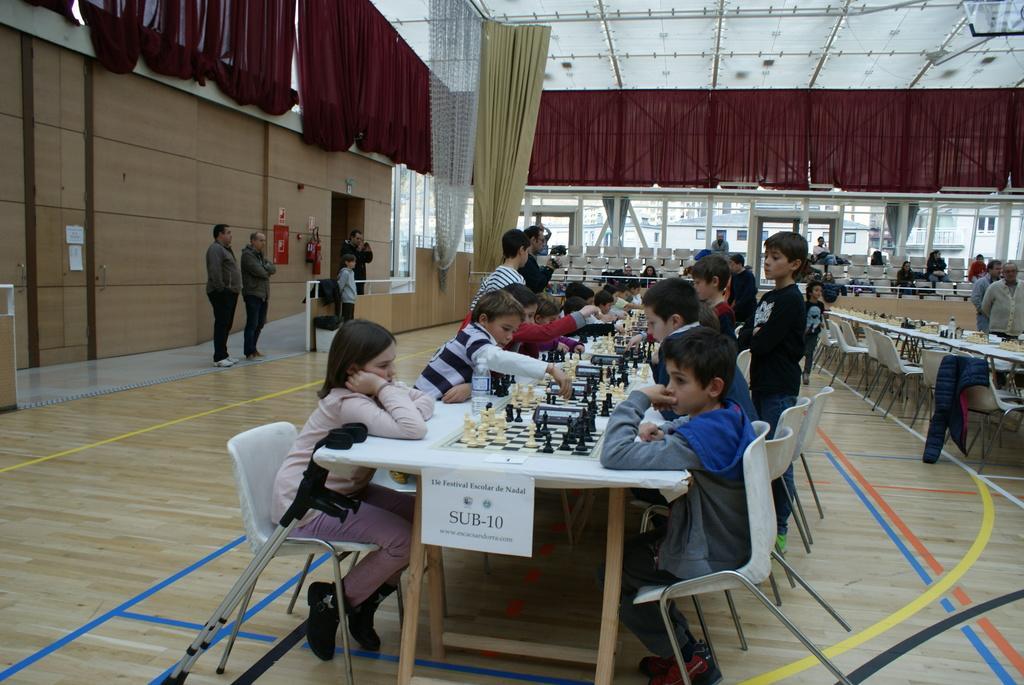Can you describe this image briefly? This image is clicked in an Auditorium. Where there is tent on the top and curtains on the top. There are so many tables and chairs. People are sitting on chairs around that tables. There are so many chess boards, chess coins and water bottles on that table. On the left side there are people standing and there are doors in the back side. 